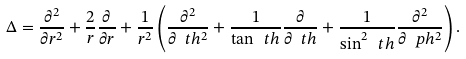<formula> <loc_0><loc_0><loc_500><loc_500>\Delta = \frac { \partial ^ { 2 } } { \partial r ^ { 2 } } + \frac { 2 } { r } \frac { \partial } { \partial r } + \frac { 1 } { r ^ { 2 } } \left ( \frac { \partial ^ { 2 } } { \partial \ t h ^ { 2 } } + \frac { 1 } { \tan \ t h } \frac { \partial } { \partial \ t h } + \frac { 1 } { \sin ^ { 2 } \ t h } \frac { \partial ^ { 2 } } { \partial \ p h ^ { 2 } } \right ) .</formula> 